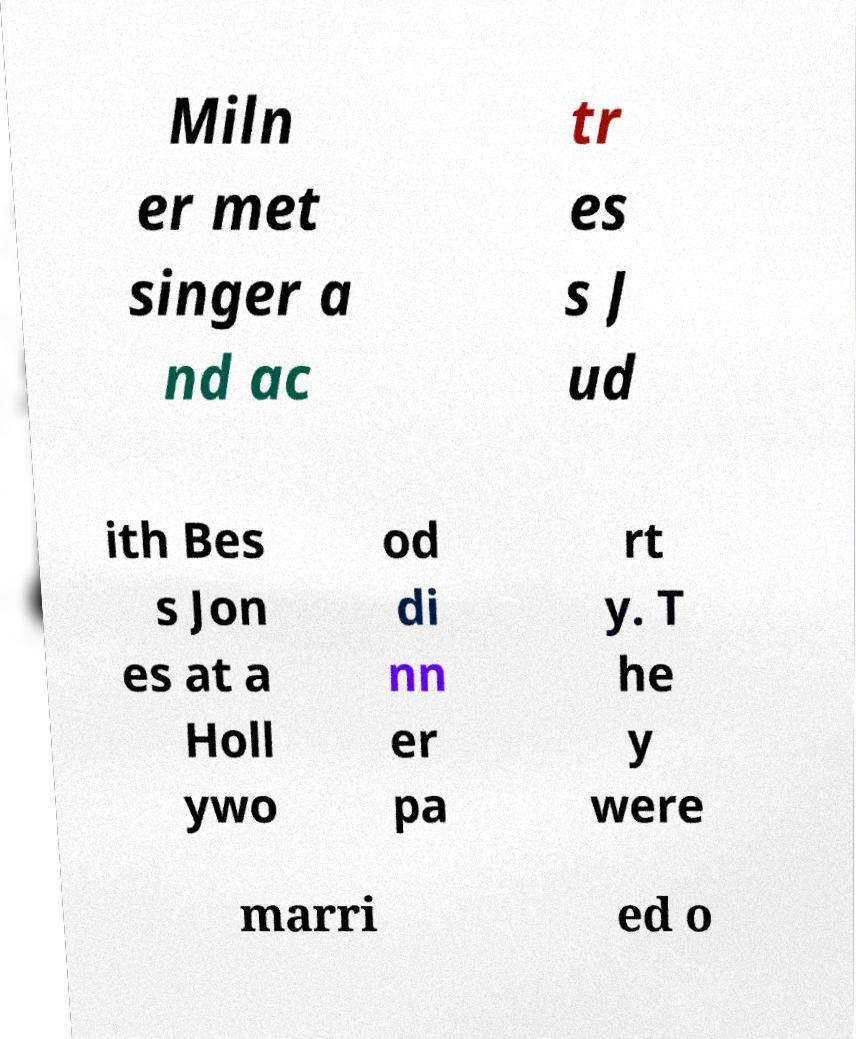Please read and relay the text visible in this image. What does it say? Miln er met singer a nd ac tr es s J ud ith Bes s Jon es at a Holl ywo od di nn er pa rt y. T he y were marri ed o 